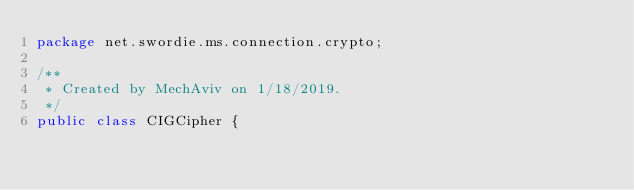<code> <loc_0><loc_0><loc_500><loc_500><_Java_>package net.swordie.ms.connection.crypto;

/**
 * Created by MechAviv on 1/18/2019.
 */
public class CIGCipher {</code> 